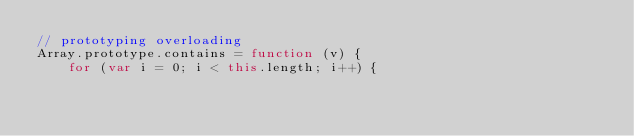Convert code to text. <code><loc_0><loc_0><loc_500><loc_500><_JavaScript_>// prototyping overloading
Array.prototype.contains = function (v) {
    for (var i = 0; i < this.length; i++) {</code> 